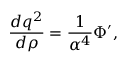Convert formula to latex. <formula><loc_0><loc_0><loc_500><loc_500>{ \frac { d q ^ { 2 } } { d \rho } } = { \frac { 1 } { \alpha ^ { 4 } } } \Phi ^ { \prime } ,</formula> 